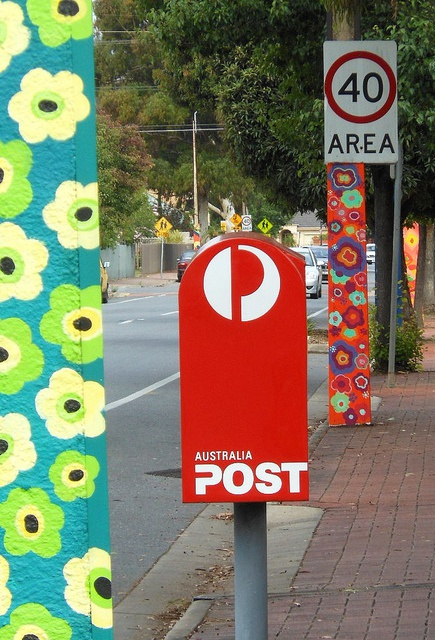Describe the objects in this image and their specific colors. I can see car in lightgreen, white, darkgray, gray, and black tones, car in lightgreen, lightgray, darkgray, and gray tones, car in lightgreen, darkgray, gray, and maroon tones, car in lightgreen, white, gray, darkgray, and black tones, and car in lightgreen, tan, and khaki tones in this image. 